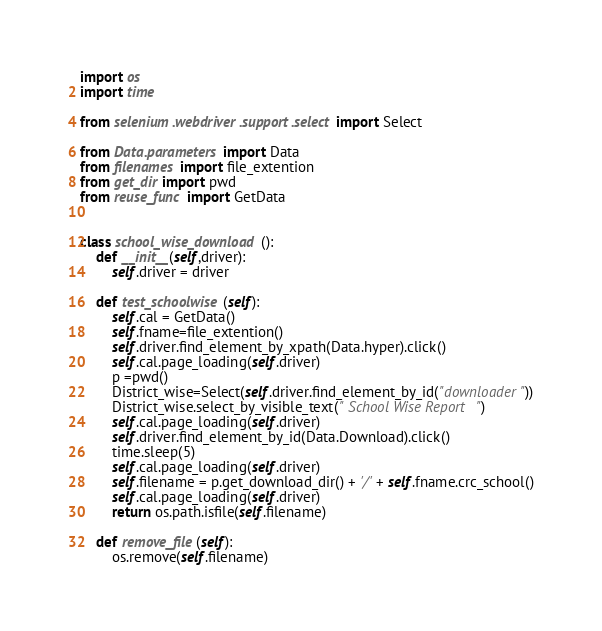<code> <loc_0><loc_0><loc_500><loc_500><_Python_>import os
import time

from selenium.webdriver.support.select import Select

from Data.parameters import Data
from filenames import file_extention
from get_dir import pwd
from reuse_func import GetData


class school_wise_download():
    def __init__(self,driver):
        self.driver = driver

    def test_schoolwise(self):
        self.cal = GetData()
        self.fname=file_extention()
        self.driver.find_element_by_xpath(Data.hyper).click()
        self.cal.page_loading(self.driver)
        p =pwd()
        District_wise=Select(self.driver.find_element_by_id("downloader"))
        District_wise.select_by_visible_text(" School Wise Report ")
        self.cal.page_loading(self.driver)
        self.driver.find_element_by_id(Data.Download).click()
        time.sleep(5)
        self.cal.page_loading(self.driver)
        self.filename = p.get_download_dir() + '/' + self.fname.crc_school()
        self.cal.page_loading(self.driver)
        return os.path.isfile(self.filename)

    def remove_file(self):
        os.remove(self.filename)


</code> 